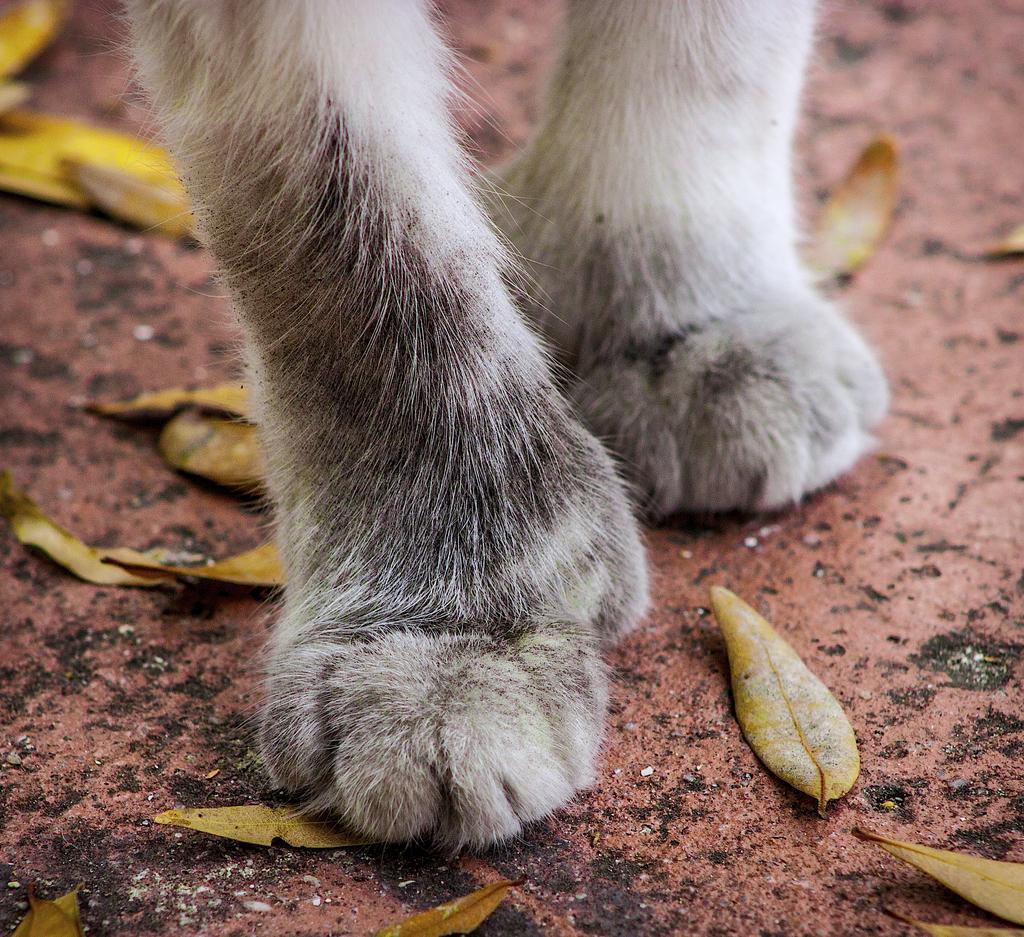Please provide a concise description of this image. In the center of the image there is an animal foot, which are in white color. And we can see leaves and a few other objects. 